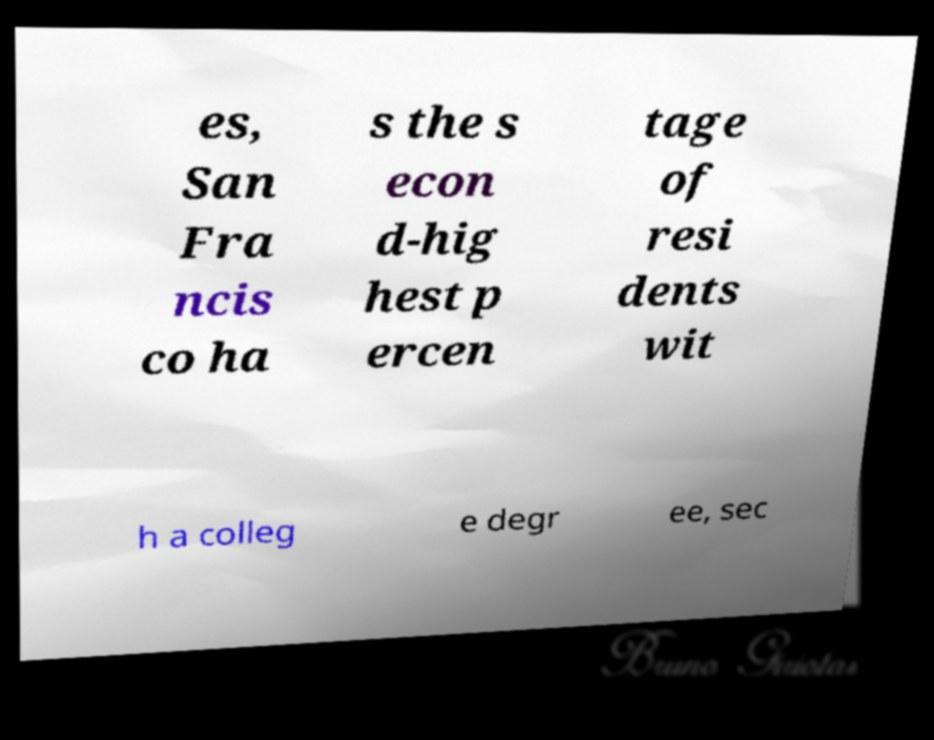For documentation purposes, I need the text within this image transcribed. Could you provide that? es, San Fra ncis co ha s the s econ d-hig hest p ercen tage of resi dents wit h a colleg e degr ee, sec 